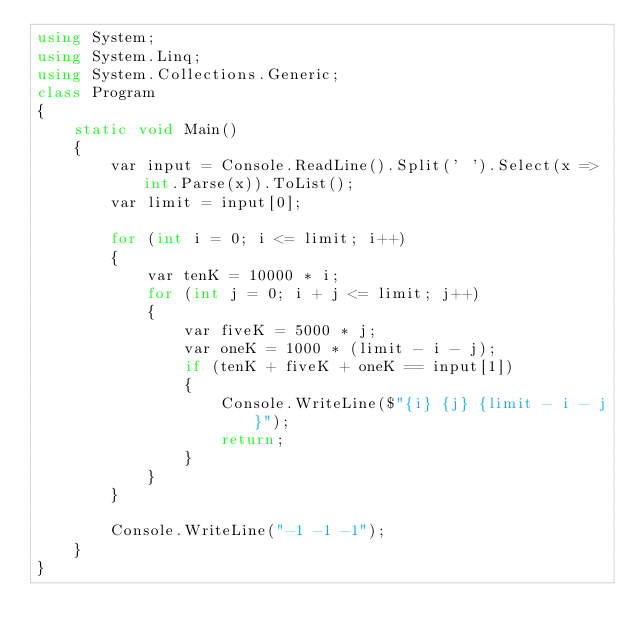<code> <loc_0><loc_0><loc_500><loc_500><_C#_>using System;
using System.Linq;
using System.Collections.Generic;
class Program
{
    static void Main()
    {
        var input = Console.ReadLine().Split(' ').Select(x => int.Parse(x)).ToList();
        var limit = input[0];

        for (int i = 0; i <= limit; i++)
        {
            var tenK = 10000 * i;
            for (int j = 0; i + j <= limit; j++)
            {
                var fiveK = 5000 * j;
                var oneK = 1000 * (limit - i - j);
                if (tenK + fiveK + oneK == input[1])
                {
                    Console.WriteLine($"{i} {j} {limit - i - j}");
                    return;
                }
            }
        }

        Console.WriteLine("-1 -1 -1");
    }
}</code> 